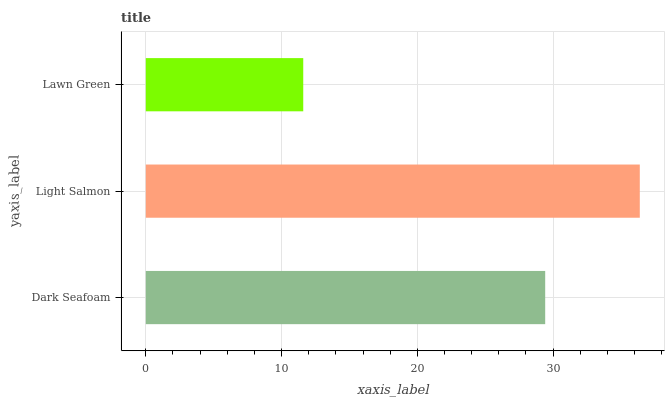Is Lawn Green the minimum?
Answer yes or no. Yes. Is Light Salmon the maximum?
Answer yes or no. Yes. Is Light Salmon the minimum?
Answer yes or no. No. Is Lawn Green the maximum?
Answer yes or no. No. Is Light Salmon greater than Lawn Green?
Answer yes or no. Yes. Is Lawn Green less than Light Salmon?
Answer yes or no. Yes. Is Lawn Green greater than Light Salmon?
Answer yes or no. No. Is Light Salmon less than Lawn Green?
Answer yes or no. No. Is Dark Seafoam the high median?
Answer yes or no. Yes. Is Dark Seafoam the low median?
Answer yes or no. Yes. Is Lawn Green the high median?
Answer yes or no. No. Is Lawn Green the low median?
Answer yes or no. No. 